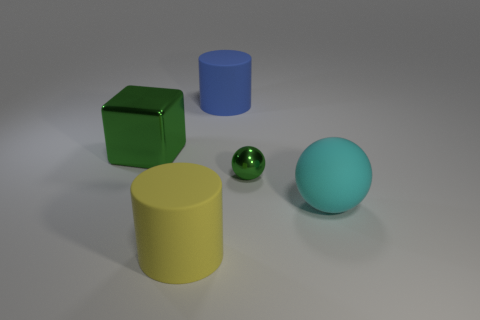Add 2 shiny cubes. How many objects exist? 7 Subtract 1 balls. How many balls are left? 1 Subtract all green spheres. How many spheres are left? 1 Subtract 0 blue blocks. How many objects are left? 5 Subtract all cylinders. How many objects are left? 3 Subtract all red balls. Subtract all cyan blocks. How many balls are left? 2 Subtract all blue cubes. How many cyan balls are left? 1 Subtract all big green metal things. Subtract all yellow cylinders. How many objects are left? 3 Add 4 big yellow cylinders. How many big yellow cylinders are left? 5 Add 4 red shiny cubes. How many red shiny cubes exist? 4 